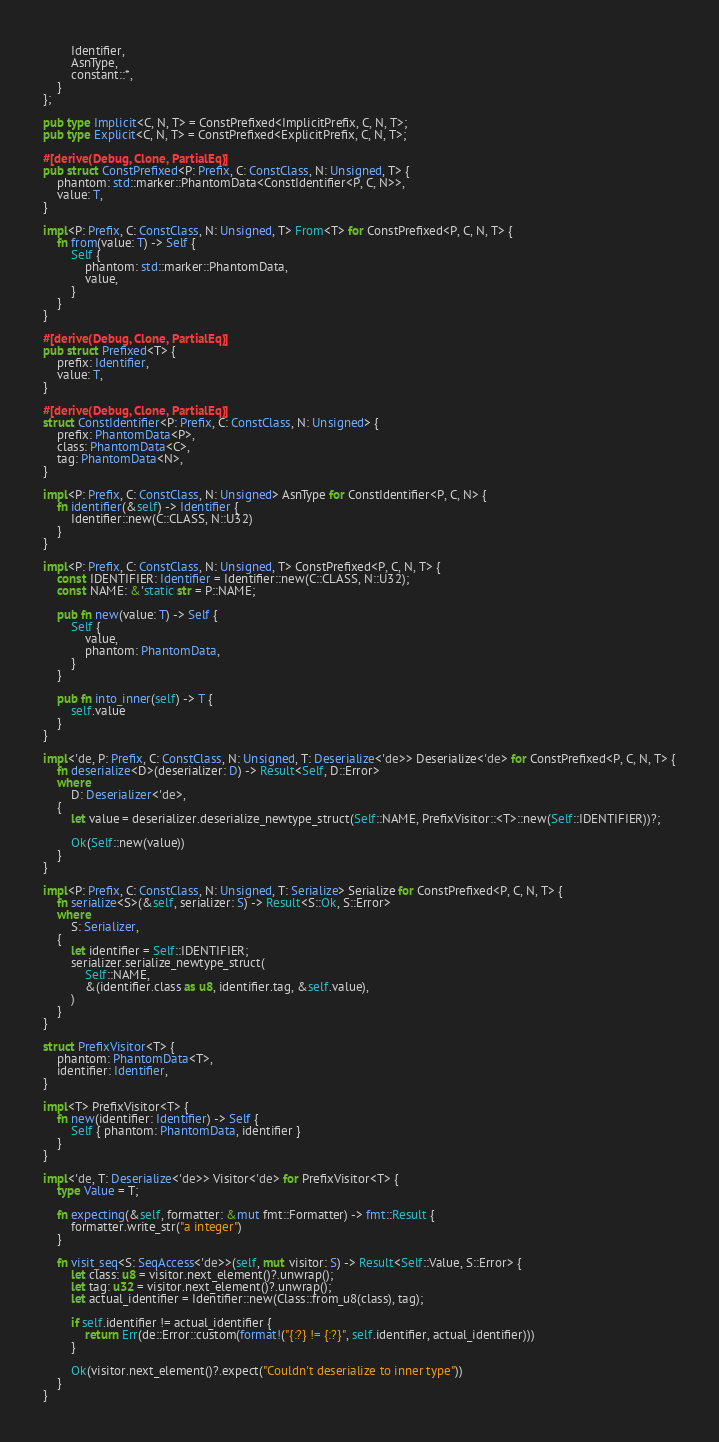Convert code to text. <code><loc_0><loc_0><loc_500><loc_500><_Rust_>        Identifier,
        AsnType,
        constant::*,
    }
};

pub type Implicit<C, N, T> = ConstPrefixed<ImplicitPrefix, C, N, T>;
pub type Explicit<C, N, T> = ConstPrefixed<ExplicitPrefix, C, N, T>;

#[derive(Debug, Clone, PartialEq)]
pub struct ConstPrefixed<P: Prefix, C: ConstClass, N: Unsigned, T> {
    phantom: std::marker::PhantomData<ConstIdentifier<P, C, N>>,
    value: T,
}

impl<P: Prefix, C: ConstClass, N: Unsigned, T> From<T> for ConstPrefixed<P, C, N, T> {
    fn from(value: T) -> Self {
        Self {
            phantom: std::marker::PhantomData,
            value,
        }
    }
}

#[derive(Debug, Clone, PartialEq)]
pub struct Prefixed<T> {
    prefix: Identifier,
    value: T,
}

#[derive(Debug, Clone, PartialEq)]
struct ConstIdentifier<P: Prefix, C: ConstClass, N: Unsigned> {
    prefix: PhantomData<P>,
    class: PhantomData<C>,
    tag: PhantomData<N>,
}

impl<P: Prefix, C: ConstClass, N: Unsigned> AsnType for ConstIdentifier<P, C, N> {
    fn identifier(&self) -> Identifier {
        Identifier::new(C::CLASS, N::U32)
    }
}

impl<P: Prefix, C: ConstClass, N: Unsigned, T> ConstPrefixed<P, C, N, T> {
    const IDENTIFIER: Identifier = Identifier::new(C::CLASS, N::U32);
    const NAME: &'static str = P::NAME;

    pub fn new(value: T) -> Self {
        Self {
            value,
            phantom: PhantomData,
        }
    }

    pub fn into_inner(self) -> T {
        self.value
    }
}

impl<'de, P: Prefix, C: ConstClass, N: Unsigned, T: Deserialize<'de>> Deserialize<'de> for ConstPrefixed<P, C, N, T> {
    fn deserialize<D>(deserializer: D) -> Result<Self, D::Error>
    where
        D: Deserializer<'de>,
    {
        let value = deserializer.deserialize_newtype_struct(Self::NAME, PrefixVisitor::<T>::new(Self::IDENTIFIER))?;

        Ok(Self::new(value))
    }
}

impl<P: Prefix, C: ConstClass, N: Unsigned, T: Serialize> Serialize for ConstPrefixed<P, C, N, T> {
    fn serialize<S>(&self, serializer: S) -> Result<S::Ok, S::Error>
    where
        S: Serializer,
    {
        let identifier = Self::IDENTIFIER;
        serializer.serialize_newtype_struct(
            Self::NAME,
            &(identifier.class as u8, identifier.tag, &self.value),
        )
    }
}

struct PrefixVisitor<T> {
    phantom: PhantomData<T>,
    identifier: Identifier,
}

impl<T> PrefixVisitor<T> {
    fn new(identifier: Identifier) -> Self {
        Self { phantom: PhantomData, identifier }
    }
}

impl<'de, T: Deserialize<'de>> Visitor<'de> for PrefixVisitor<T> {
    type Value = T;

    fn expecting(&self, formatter: &mut fmt::Formatter) -> fmt::Result {
        formatter.write_str("a integer")
    }

    fn visit_seq<S: SeqAccess<'de>>(self, mut visitor: S) -> Result<Self::Value, S::Error> {
        let class: u8 = visitor.next_element()?.unwrap();
        let tag: u32 = visitor.next_element()?.unwrap();
        let actual_identifier = Identifier::new(Class::from_u8(class), tag);

        if self.identifier != actual_identifier {
            return Err(de::Error::custom(format!("{:?} != {:?}", self.identifier, actual_identifier)))
        }

        Ok(visitor.next_element()?.expect("Couldn't deserialize to inner type"))
    }
}

</code> 